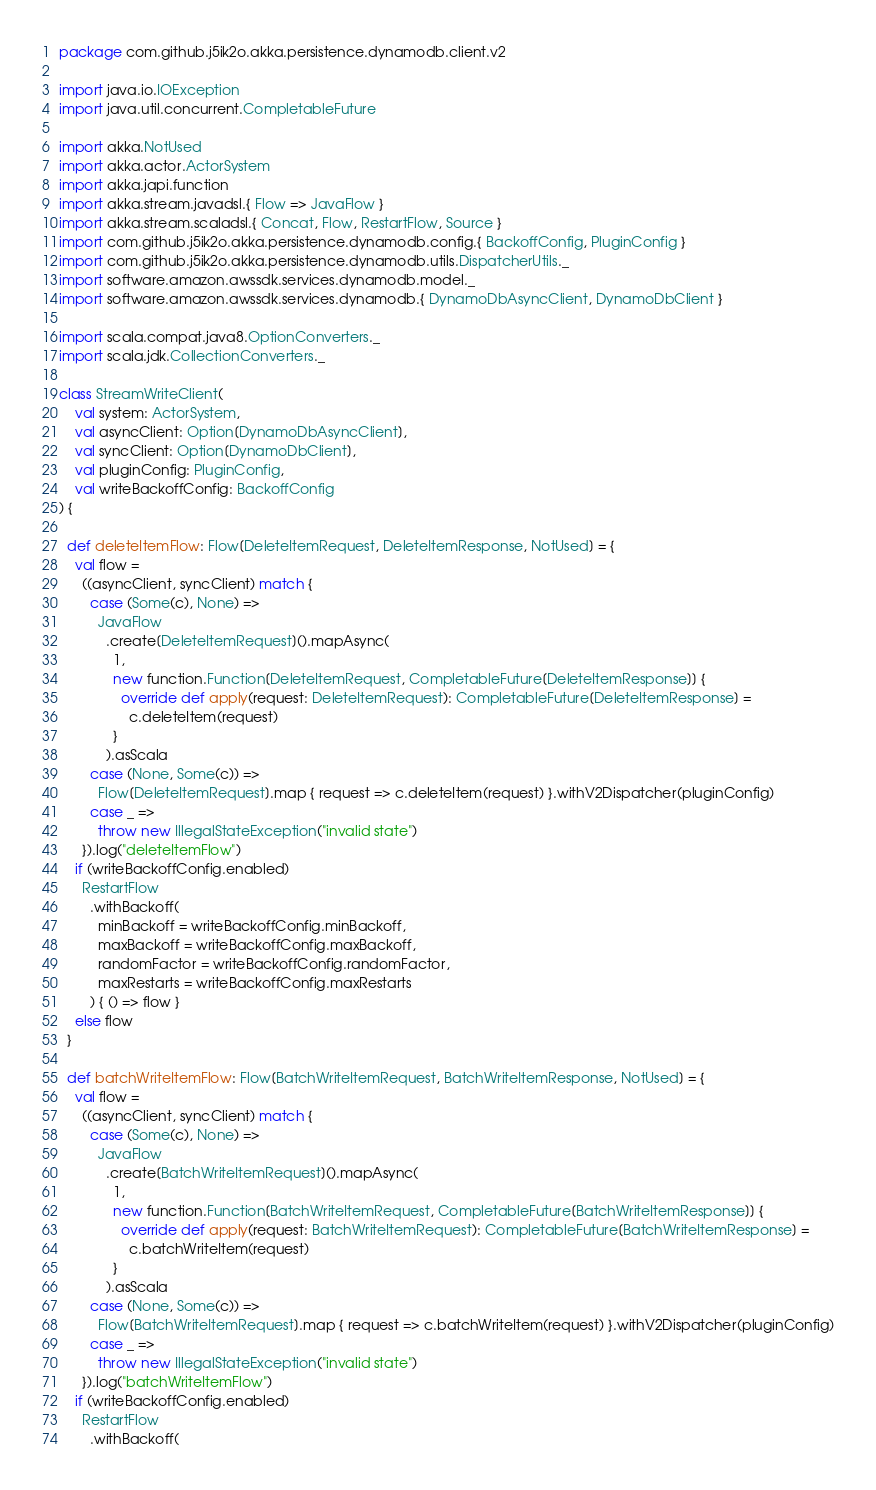<code> <loc_0><loc_0><loc_500><loc_500><_Scala_>package com.github.j5ik2o.akka.persistence.dynamodb.client.v2

import java.io.IOException
import java.util.concurrent.CompletableFuture

import akka.NotUsed
import akka.actor.ActorSystem
import akka.japi.function
import akka.stream.javadsl.{ Flow => JavaFlow }
import akka.stream.scaladsl.{ Concat, Flow, RestartFlow, Source }
import com.github.j5ik2o.akka.persistence.dynamodb.config.{ BackoffConfig, PluginConfig }
import com.github.j5ik2o.akka.persistence.dynamodb.utils.DispatcherUtils._
import software.amazon.awssdk.services.dynamodb.model._
import software.amazon.awssdk.services.dynamodb.{ DynamoDbAsyncClient, DynamoDbClient }

import scala.compat.java8.OptionConverters._
import scala.jdk.CollectionConverters._

class StreamWriteClient(
    val system: ActorSystem,
    val asyncClient: Option[DynamoDbAsyncClient],
    val syncClient: Option[DynamoDbClient],
    val pluginConfig: PluginConfig,
    val writeBackoffConfig: BackoffConfig
) {

  def deleteItemFlow: Flow[DeleteItemRequest, DeleteItemResponse, NotUsed] = {
    val flow =
      ((asyncClient, syncClient) match {
        case (Some(c), None) =>
          JavaFlow
            .create[DeleteItemRequest]().mapAsync(
              1,
              new function.Function[DeleteItemRequest, CompletableFuture[DeleteItemResponse]] {
                override def apply(request: DeleteItemRequest): CompletableFuture[DeleteItemResponse] =
                  c.deleteItem(request)
              }
            ).asScala
        case (None, Some(c)) =>
          Flow[DeleteItemRequest].map { request => c.deleteItem(request) }.withV2Dispatcher(pluginConfig)
        case _ =>
          throw new IllegalStateException("invalid state")
      }).log("deleteItemFlow")
    if (writeBackoffConfig.enabled)
      RestartFlow
        .withBackoff(
          minBackoff = writeBackoffConfig.minBackoff,
          maxBackoff = writeBackoffConfig.maxBackoff,
          randomFactor = writeBackoffConfig.randomFactor,
          maxRestarts = writeBackoffConfig.maxRestarts
        ) { () => flow }
    else flow
  }

  def batchWriteItemFlow: Flow[BatchWriteItemRequest, BatchWriteItemResponse, NotUsed] = {
    val flow =
      ((asyncClient, syncClient) match {
        case (Some(c), None) =>
          JavaFlow
            .create[BatchWriteItemRequest]().mapAsync(
              1,
              new function.Function[BatchWriteItemRequest, CompletableFuture[BatchWriteItemResponse]] {
                override def apply(request: BatchWriteItemRequest): CompletableFuture[BatchWriteItemResponse] =
                  c.batchWriteItem(request)
              }
            ).asScala
        case (None, Some(c)) =>
          Flow[BatchWriteItemRequest].map { request => c.batchWriteItem(request) }.withV2Dispatcher(pluginConfig)
        case _ =>
          throw new IllegalStateException("invalid state")
      }).log("batchWriteItemFlow")
    if (writeBackoffConfig.enabled)
      RestartFlow
        .withBackoff(</code> 